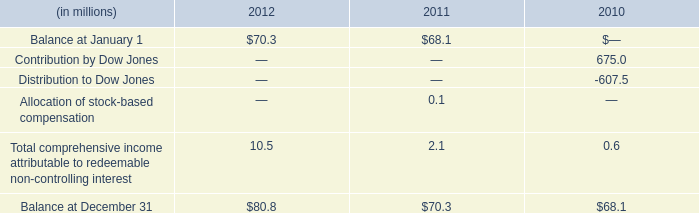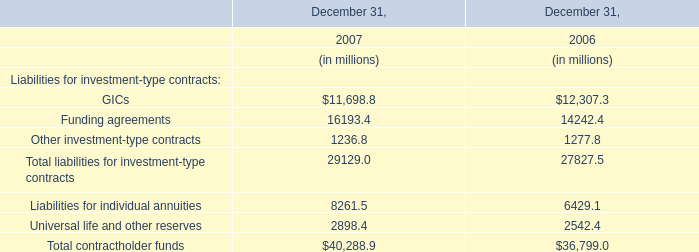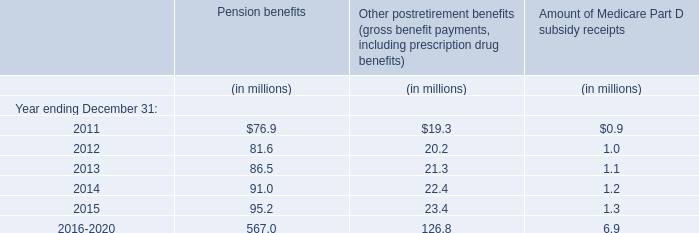what is the percentage change in the balance of non-controlling interests from 2010 to 2011? 
Computations: ((70.3 - 68.1) / 68.1)
Answer: 0.03231. 